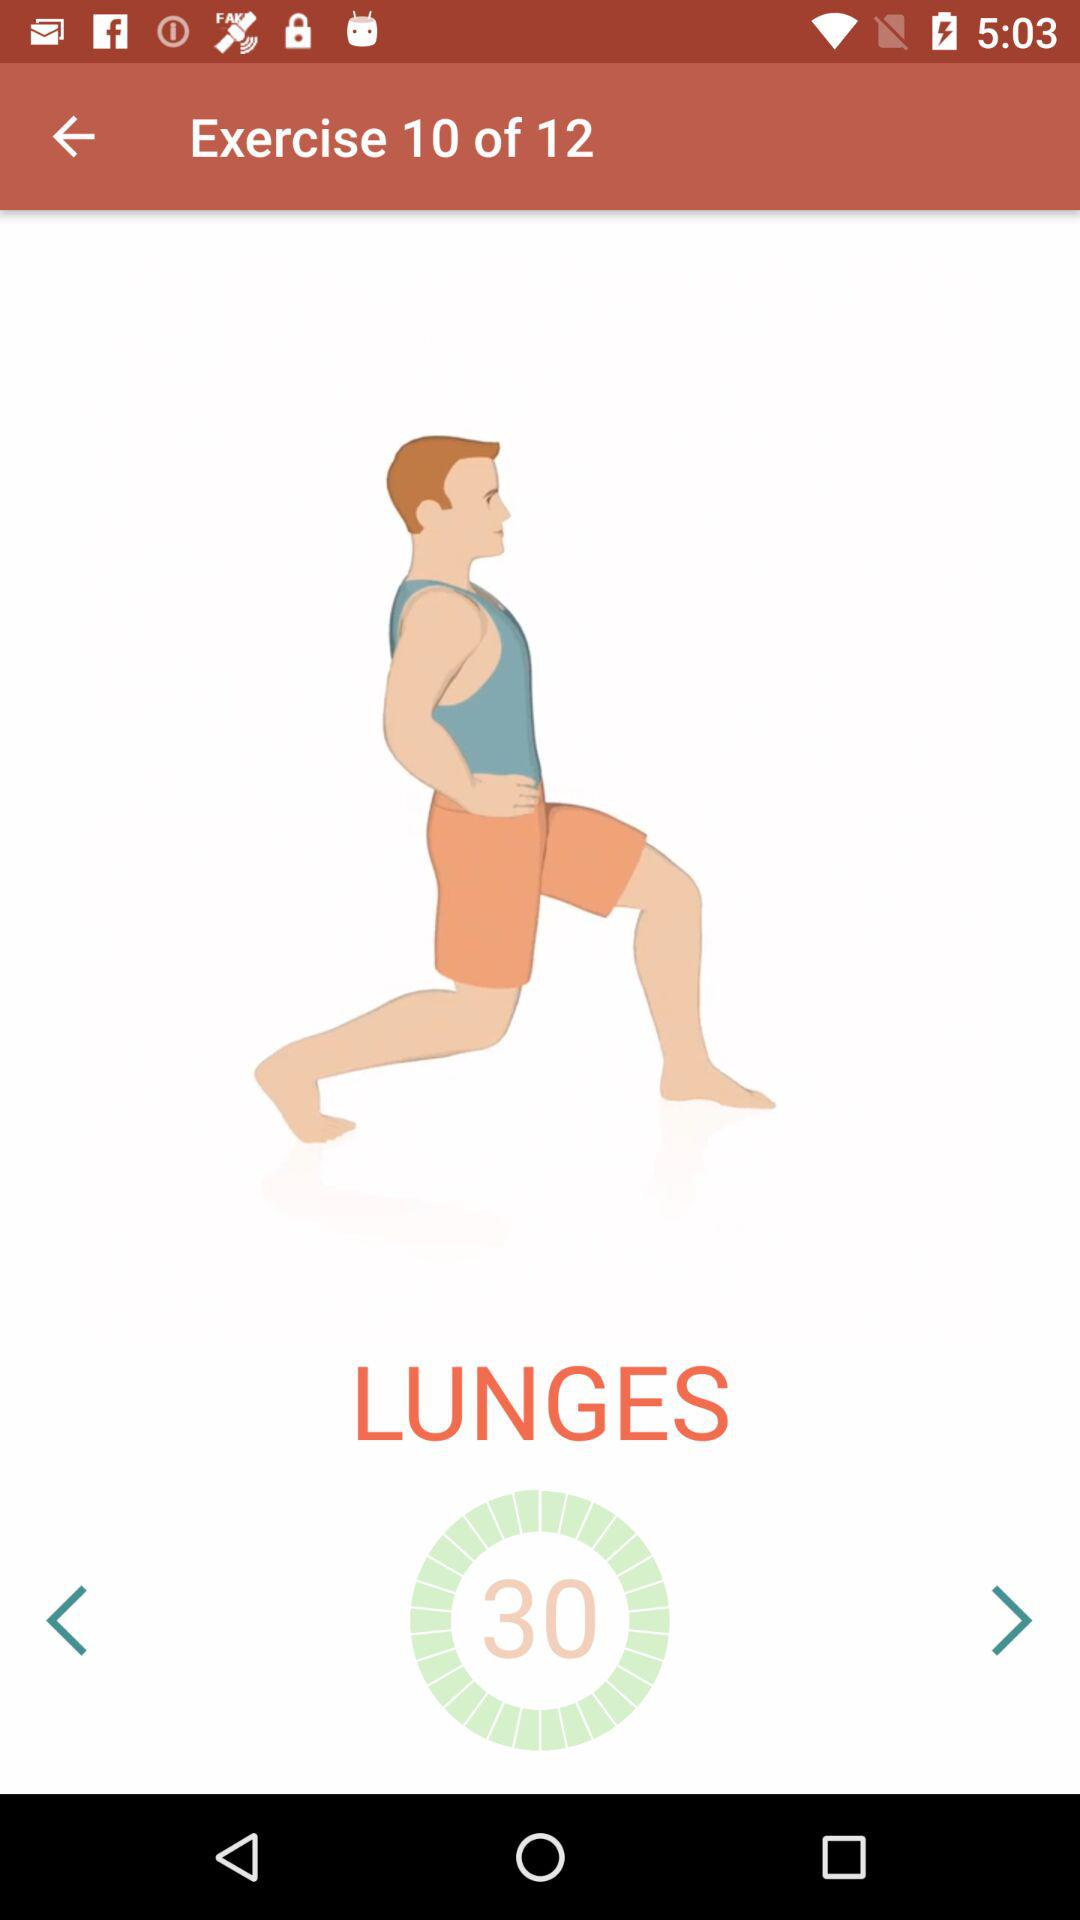Which exercise am I doing? You are doing lunges. 